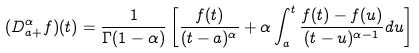Convert formula to latex. <formula><loc_0><loc_0><loc_500><loc_500>( D ^ { \alpha } _ { a + } f ) ( t ) = \frac { 1 } { \Gamma ( 1 - \alpha ) } \left [ \frac { f ( t ) } { ( t - a ) ^ { \alpha } } + \alpha \int ^ { t } _ { a } \frac { f ( t ) - f ( u ) } { ( t - u ) ^ { \alpha - 1 } } d u \right ]</formula> 